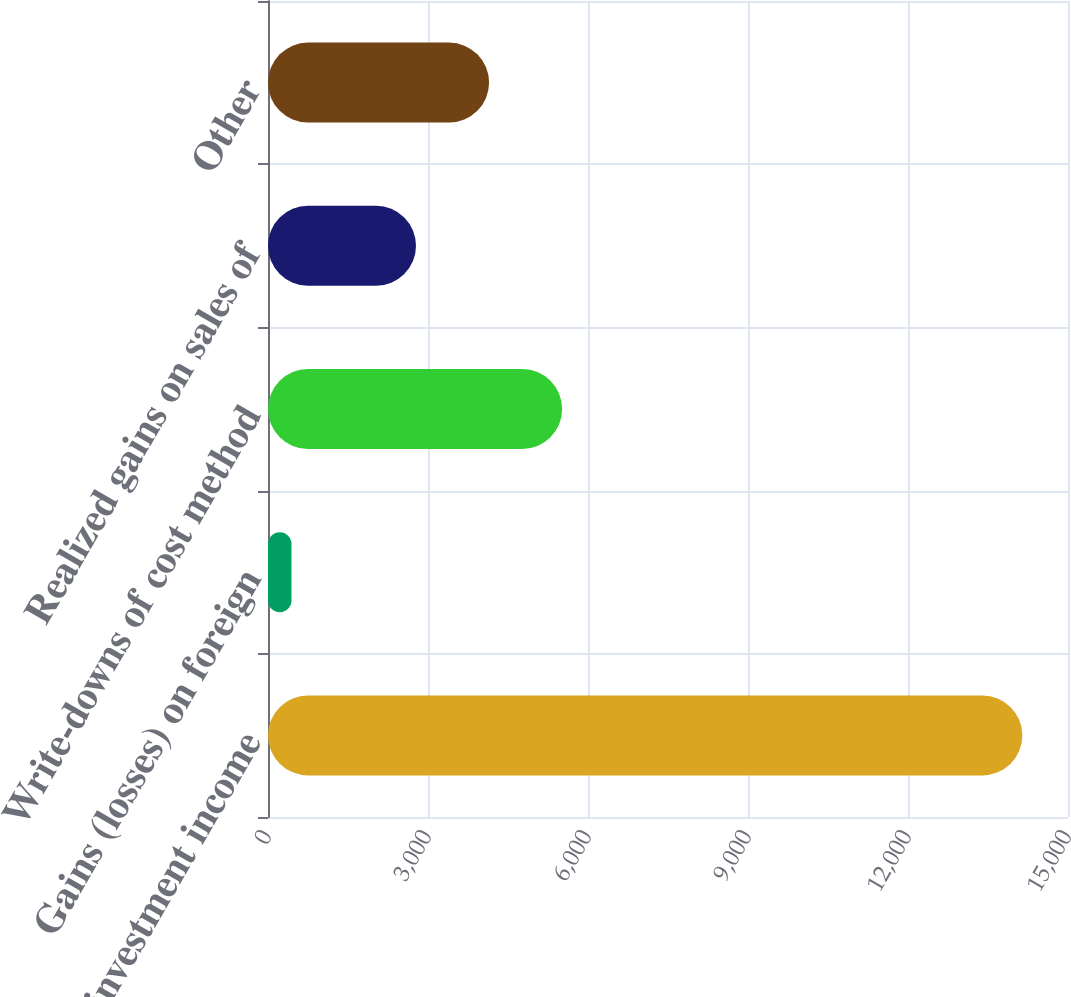<chart> <loc_0><loc_0><loc_500><loc_500><bar_chart><fcel>Interest and investment income<fcel>Gains (losses) on foreign<fcel>Write-downs of cost method<fcel>Realized gains on sales of<fcel>Other<nl><fcel>14144<fcel>440<fcel>5515.8<fcel>2775<fcel>4145.4<nl></chart> 